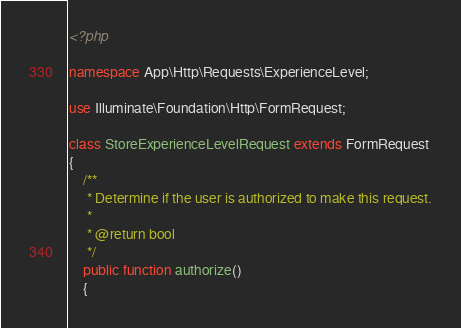<code> <loc_0><loc_0><loc_500><loc_500><_PHP_><?php

namespace App\Http\Requests\ExperienceLevel;

use Illuminate\Foundation\Http\FormRequest;

class StoreExperienceLevelRequest extends FormRequest
{
    /**
     * Determine if the user is authorized to make this request.
     *
     * @return bool
     */
    public function authorize()
    {</code> 